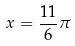Convert formula to latex. <formula><loc_0><loc_0><loc_500><loc_500>x = \frac { 1 1 } { 6 } \pi</formula> 